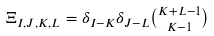<formula> <loc_0><loc_0><loc_500><loc_500>\Xi _ { I , J , K , L } = \delta _ { I - K } \delta _ { J - L } \tbinom { K + L - 1 } { K - 1 }</formula> 